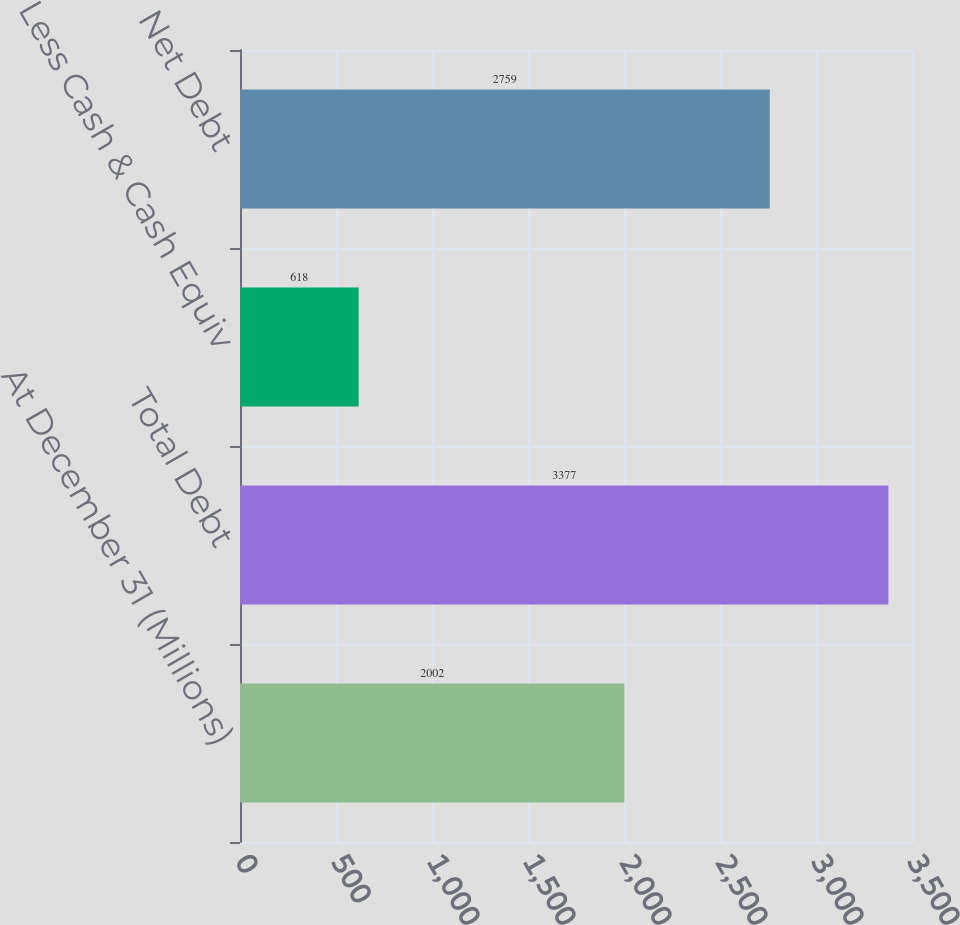Convert chart to OTSL. <chart><loc_0><loc_0><loc_500><loc_500><bar_chart><fcel>At December 31 (Millions)<fcel>Total Debt<fcel>Less Cash & Cash Equiv<fcel>Net Debt<nl><fcel>2002<fcel>3377<fcel>618<fcel>2759<nl></chart> 